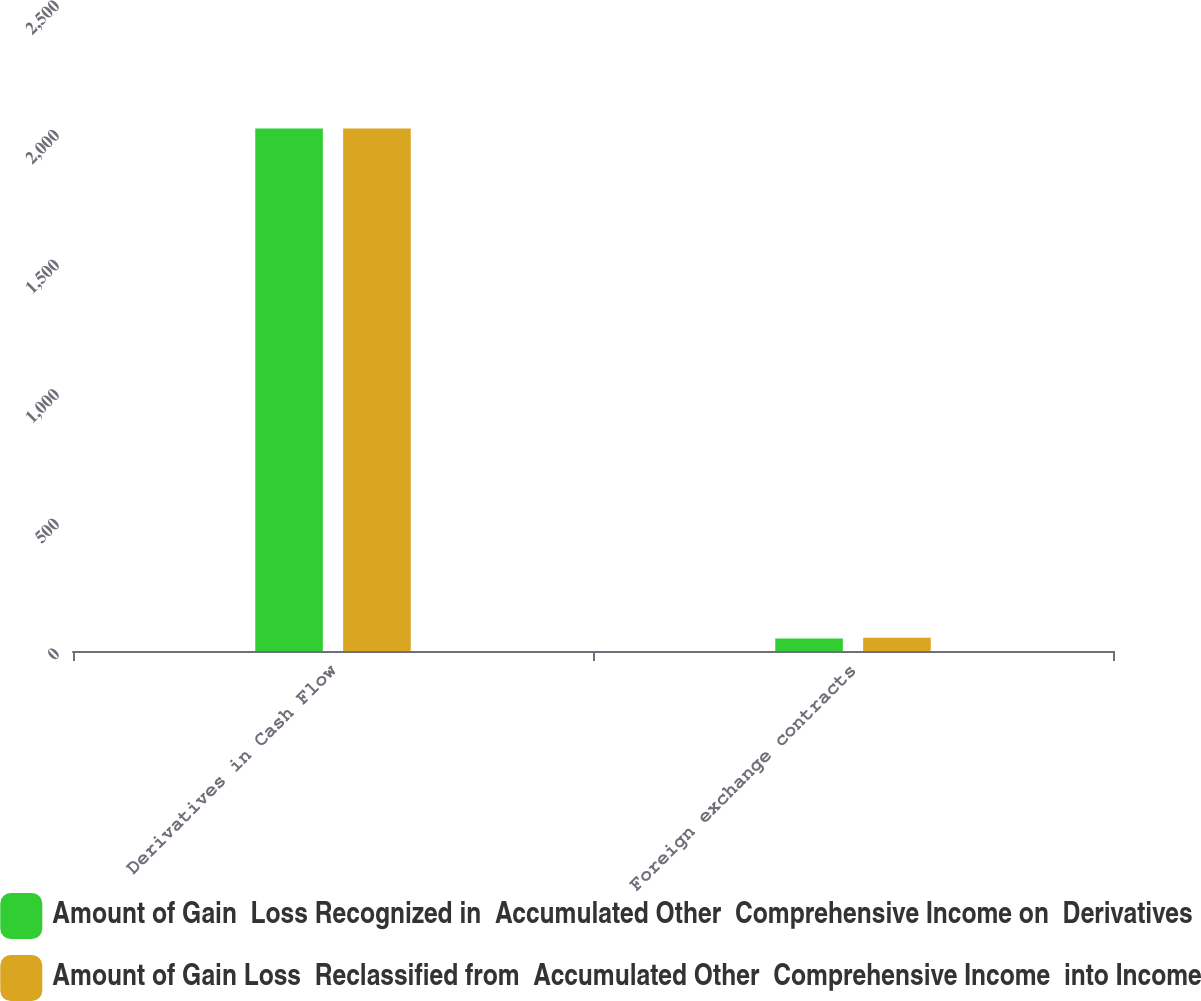<chart> <loc_0><loc_0><loc_500><loc_500><stacked_bar_chart><ecel><fcel>Derivatives in Cash Flow<fcel>Foreign exchange contracts<nl><fcel>Amount of Gain  Loss Recognized in  Accumulated Other  Comprehensive Income on  Derivatives<fcel>2016<fcel>48<nl><fcel>Amount of Gain Loss  Reclassified from  Accumulated Other  Comprehensive Income  into Income<fcel>2016<fcel>51<nl></chart> 